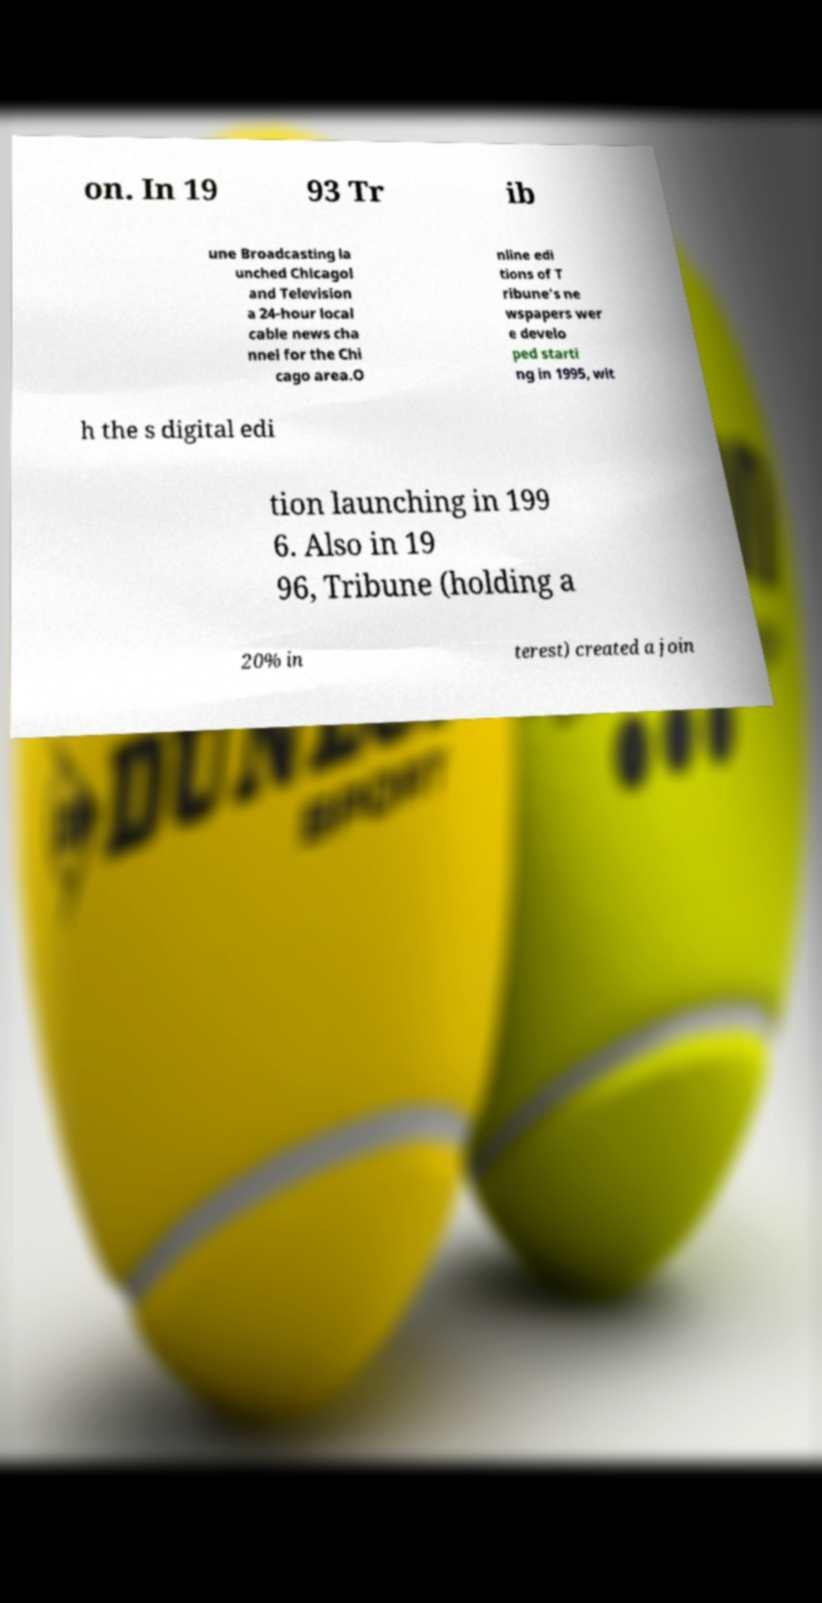Could you assist in decoding the text presented in this image and type it out clearly? on. In 19 93 Tr ib une Broadcasting la unched Chicagol and Television a 24-hour local cable news cha nnel for the Chi cago area.O nline edi tions of T ribune's ne wspapers wer e develo ped starti ng in 1995, wit h the s digital edi tion launching in 199 6. Also in 19 96, Tribune (holding a 20% in terest) created a join 